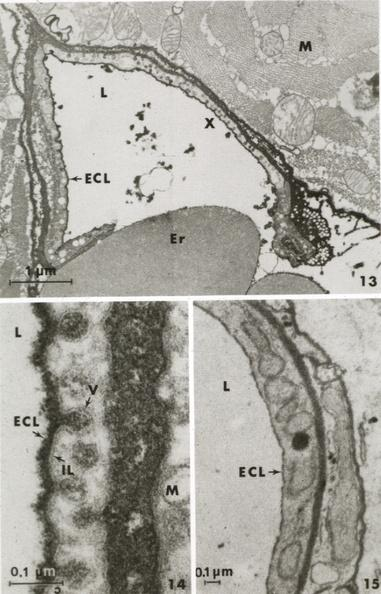what is present?
Answer the question using a single word or phrase. Vasculature 